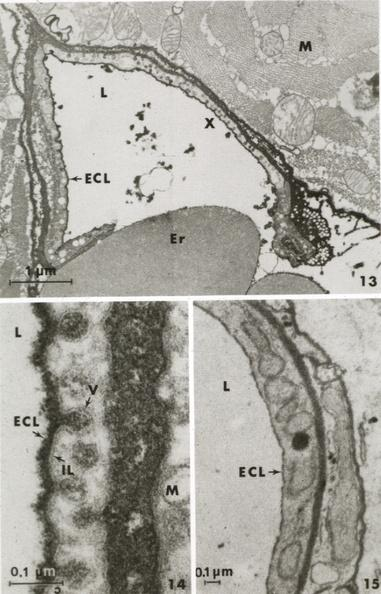what is present?
Answer the question using a single word or phrase. Vasculature 